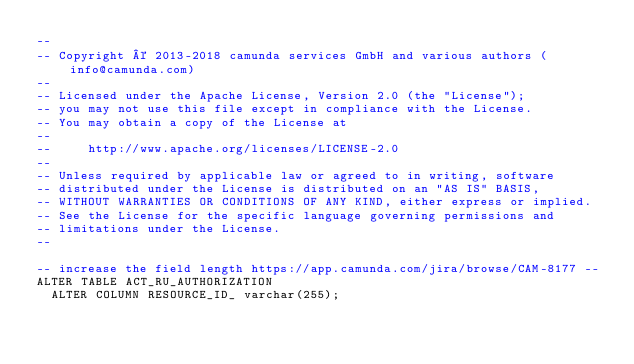Convert code to text. <code><loc_0><loc_0><loc_500><loc_500><_SQL_>--
-- Copyright © 2013-2018 camunda services GmbH and various authors (info@camunda.com)
--
-- Licensed under the Apache License, Version 2.0 (the "License");
-- you may not use this file except in compliance with the License.
-- You may obtain a copy of the License at
--
--     http://www.apache.org/licenses/LICENSE-2.0
--
-- Unless required by applicable law or agreed to in writing, software
-- distributed under the License is distributed on an "AS IS" BASIS,
-- WITHOUT WARRANTIES OR CONDITIONS OF ANY KIND, either express or implied.
-- See the License for the specific language governing permissions and
-- limitations under the License.
--

-- increase the field length https://app.camunda.com/jira/browse/CAM-8177 --
ALTER TABLE ACT_RU_AUTHORIZATION 
  ALTER COLUMN RESOURCE_ID_ varchar(255);</code> 